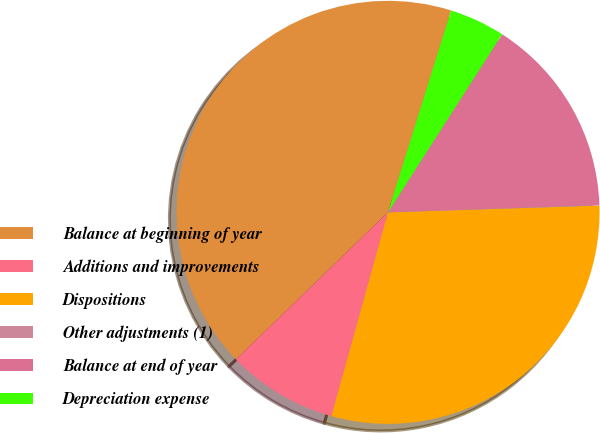Convert chart. <chart><loc_0><loc_0><loc_500><loc_500><pie_chart><fcel>Balance at beginning of year<fcel>Additions and improvements<fcel>Dispositions<fcel>Other adjustments (1)<fcel>Balance at end of year<fcel>Depreciation expense<nl><fcel>42.06%<fcel>8.45%<fcel>29.82%<fcel>0.05%<fcel>15.36%<fcel>4.25%<nl></chart> 